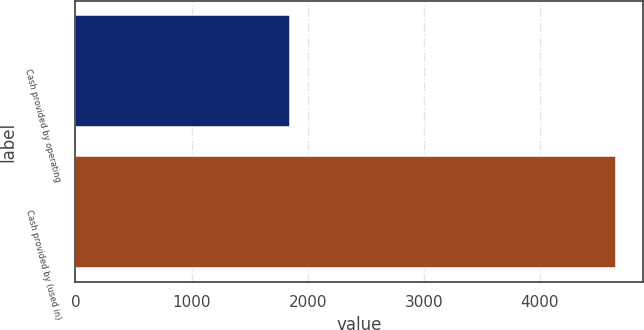Convert chart to OTSL. <chart><loc_0><loc_0><loc_500><loc_500><bar_chart><fcel>Cash provided by operating<fcel>Cash provided by (used in)<nl><fcel>1851<fcel>4660<nl></chart> 